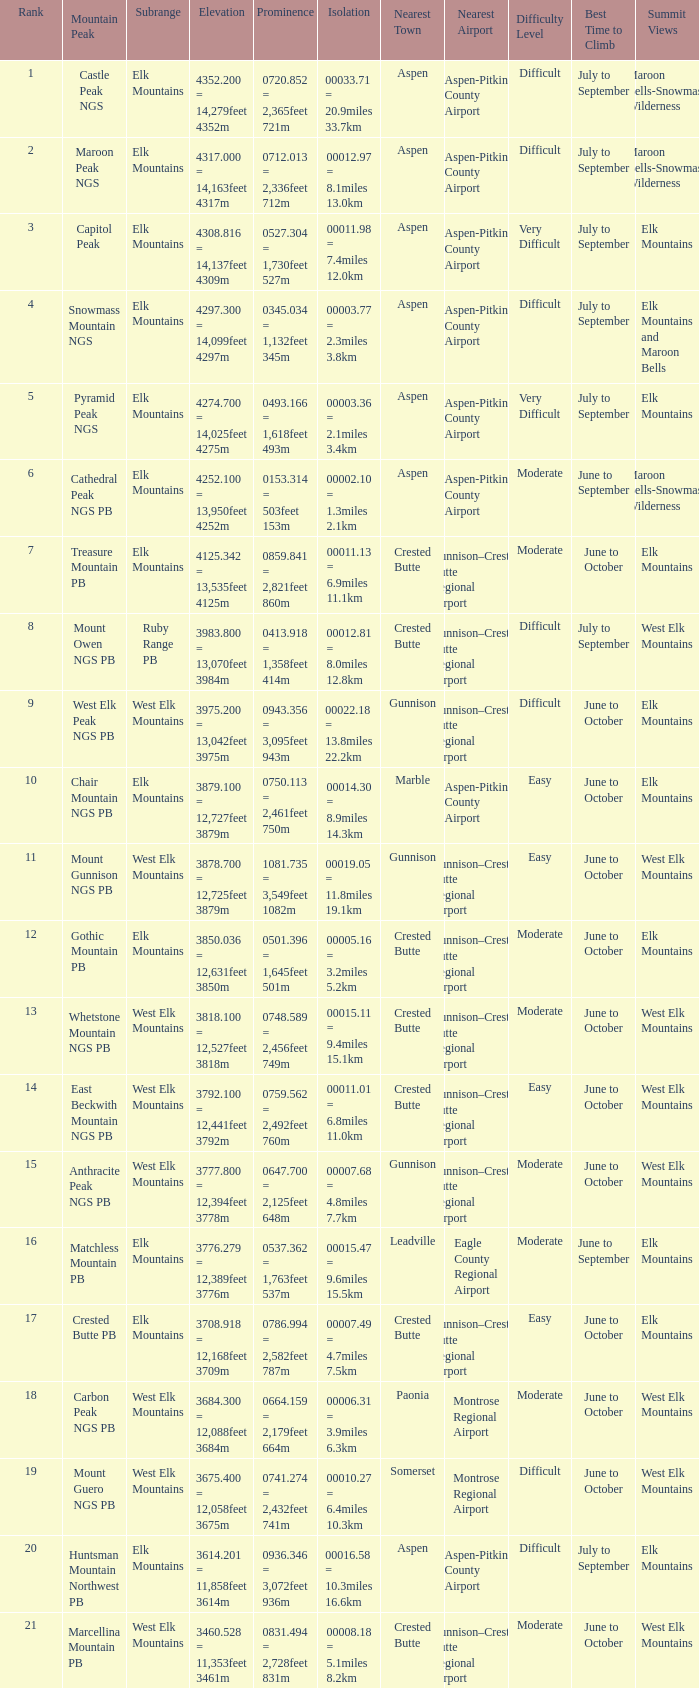Name the Rank of Rank Mountain Peak of crested butte pb? 17.0. 